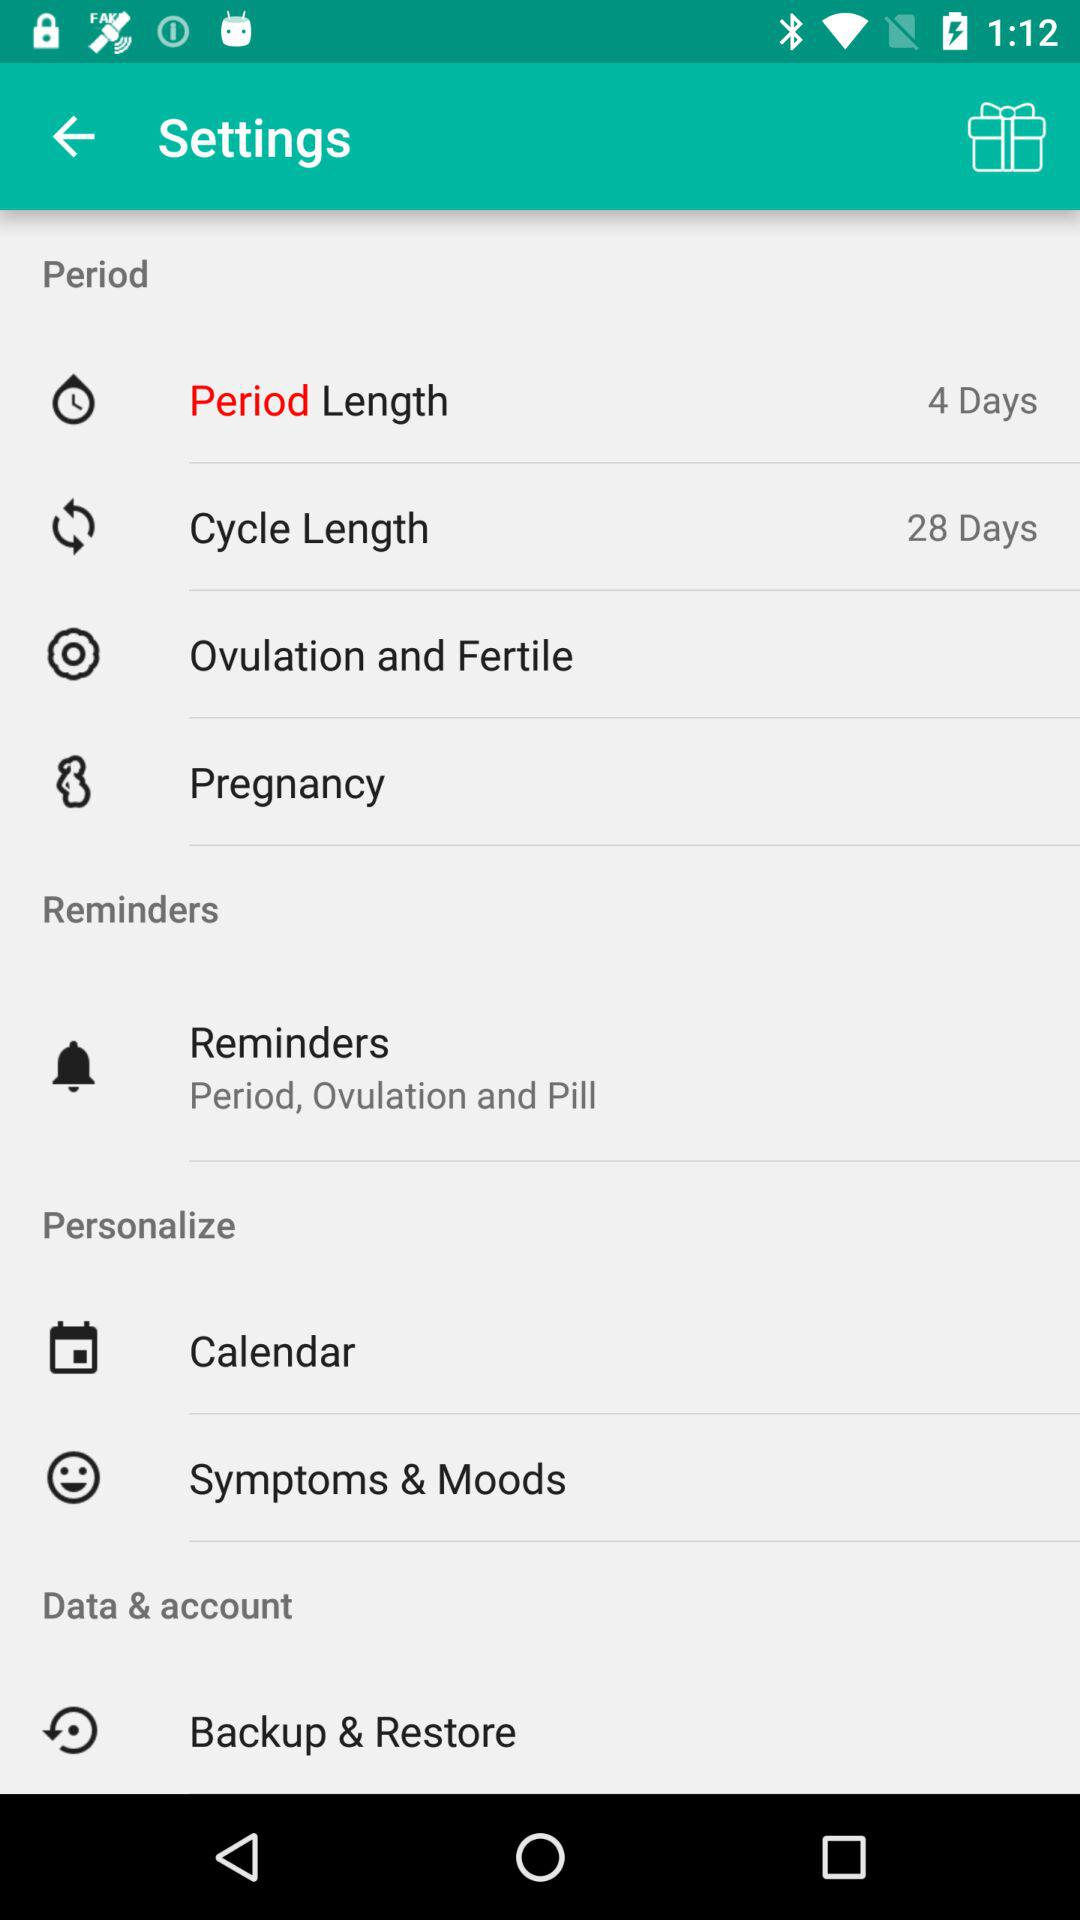What is the period length? The period length is 4 days. 